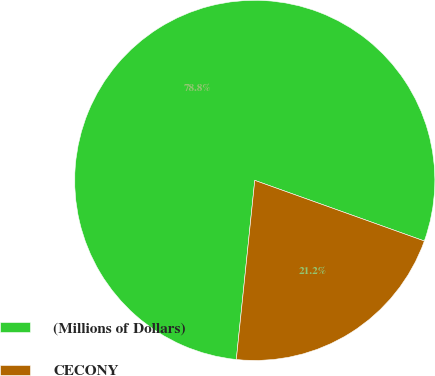<chart> <loc_0><loc_0><loc_500><loc_500><pie_chart><fcel>(Millions of Dollars)<fcel>CECONY<nl><fcel>78.83%<fcel>21.17%<nl></chart> 